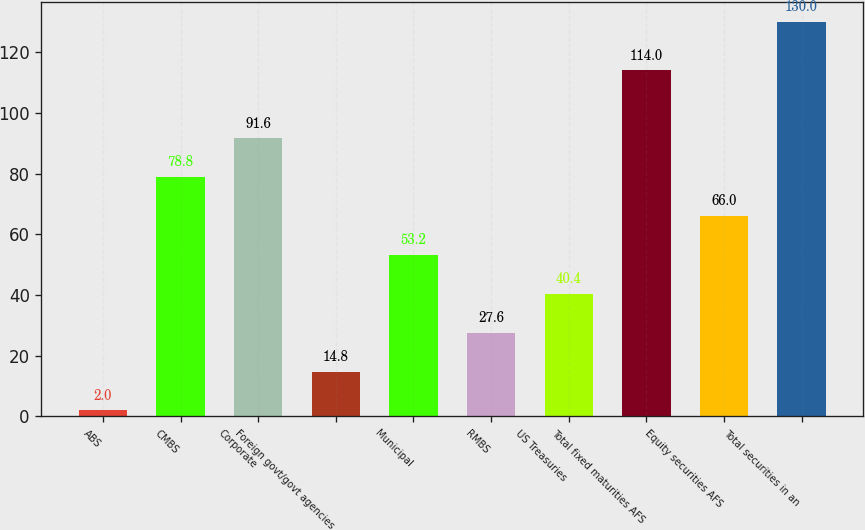<chart> <loc_0><loc_0><loc_500><loc_500><bar_chart><fcel>ABS<fcel>CMBS<fcel>Corporate<fcel>Foreign govt/govt agencies<fcel>Municipal<fcel>RMBS<fcel>US Treasuries<fcel>Total fixed maturities AFS<fcel>Equity securities AFS<fcel>Total securities in an<nl><fcel>2<fcel>78.8<fcel>91.6<fcel>14.8<fcel>53.2<fcel>27.6<fcel>40.4<fcel>114<fcel>66<fcel>130<nl></chart> 